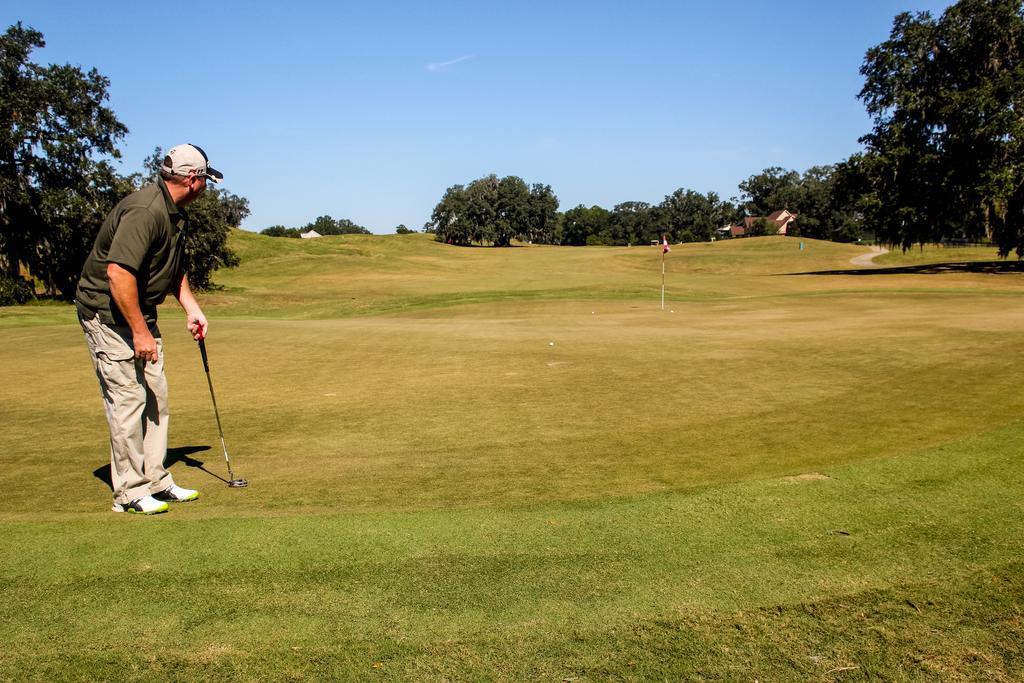Describe this image in one or two sentences. In the picture there is a man he is playing golf in the ground and around the ground there are lot of trees. 